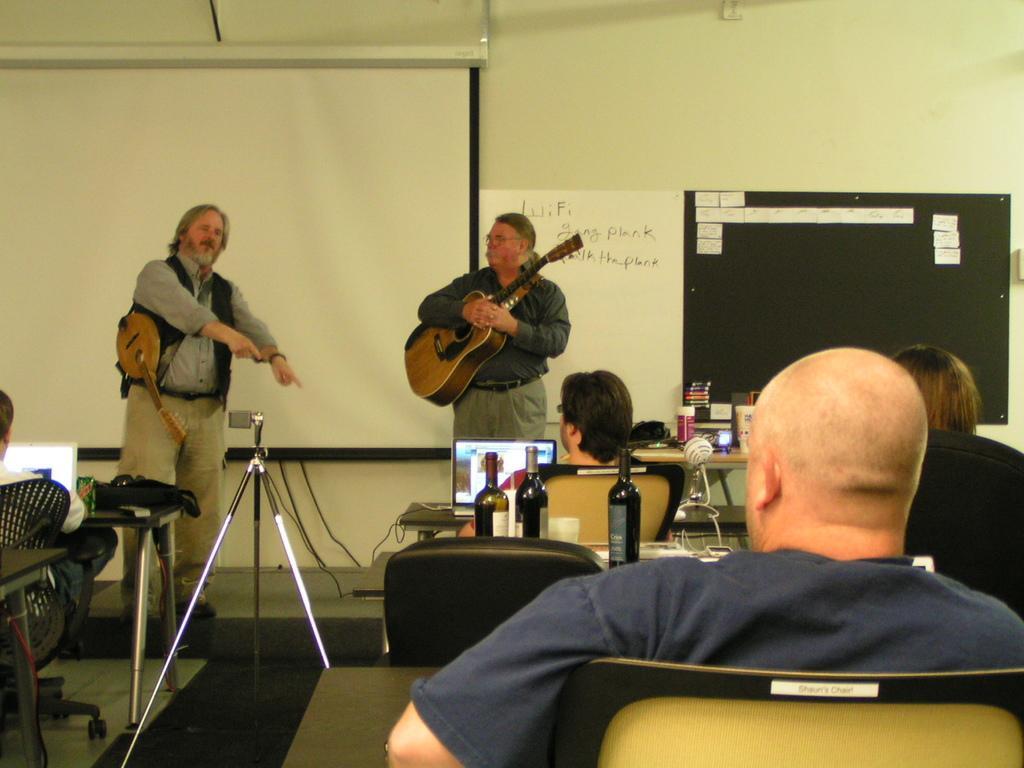How would you summarize this image in a sentence or two? In this picture we can see two persons standing on the floor. He is holding a guitar. And here we can see few persons are sitting on the chairs. These are the bottles. And there is a screen. On the background there is a wall. And this is the floor. 